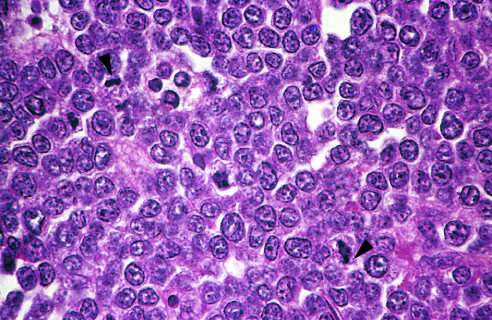re those with tumors that had mycn amplification better appreciated at a lower magnification?
Answer the question using a single word or phrase. No 